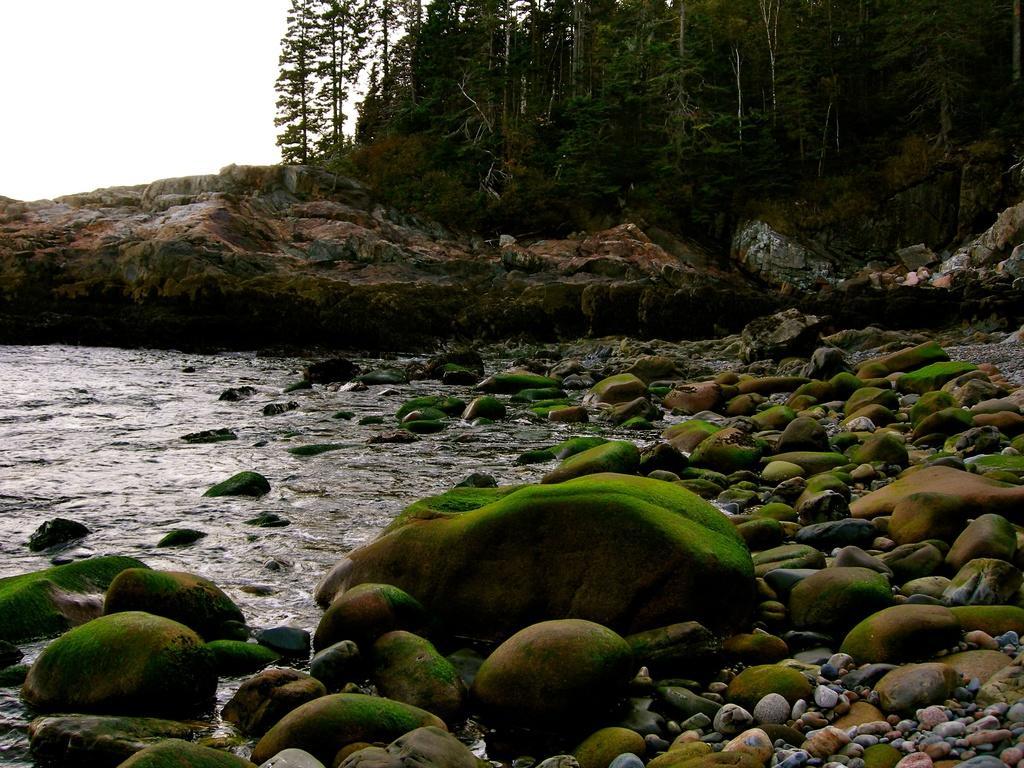Could you give a brief overview of what you see in this image? In this image I can see stones, water, mountains and trees. On the top left I can see the sky. This image is taken during a day may be near the ocean. 